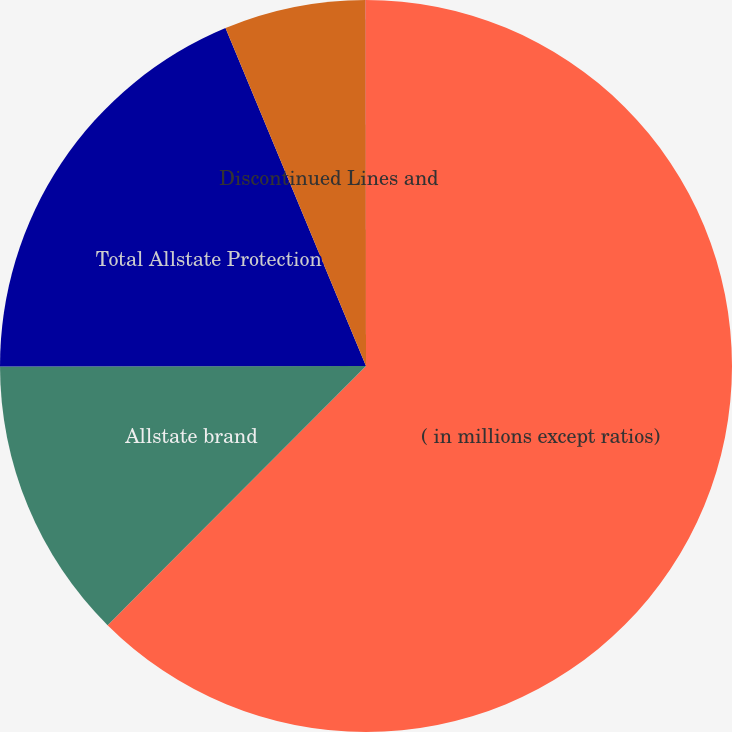<chart> <loc_0><loc_0><loc_500><loc_500><pie_chart><fcel>( in millions except ratios)<fcel>Allstate brand<fcel>Total Allstate Protection<fcel>Discontinued Lines and<fcel>Total Property-Liability (3)<nl><fcel>62.47%<fcel>12.5%<fcel>18.75%<fcel>6.26%<fcel>0.01%<nl></chart> 